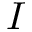Convert formula to latex. <formula><loc_0><loc_0><loc_500><loc_500>I</formula> 